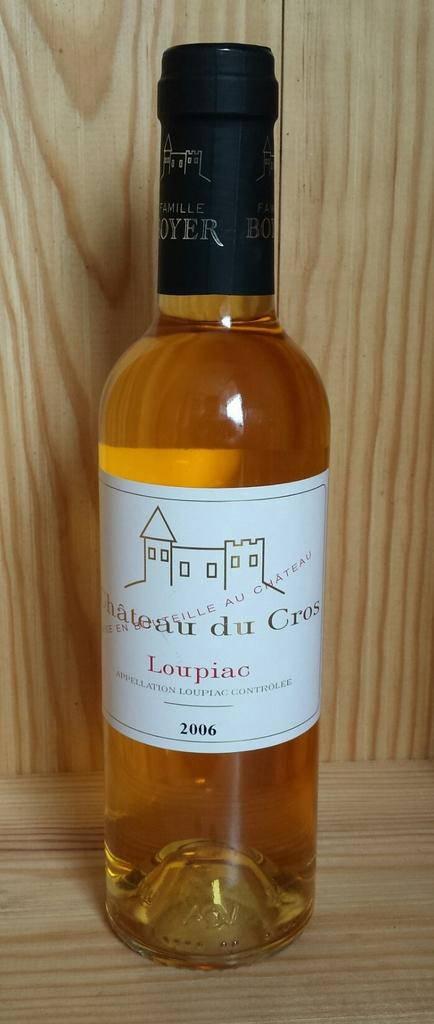<image>
Write a terse but informative summary of the picture. A bottle of wine with the words Chateau du Cros visible 